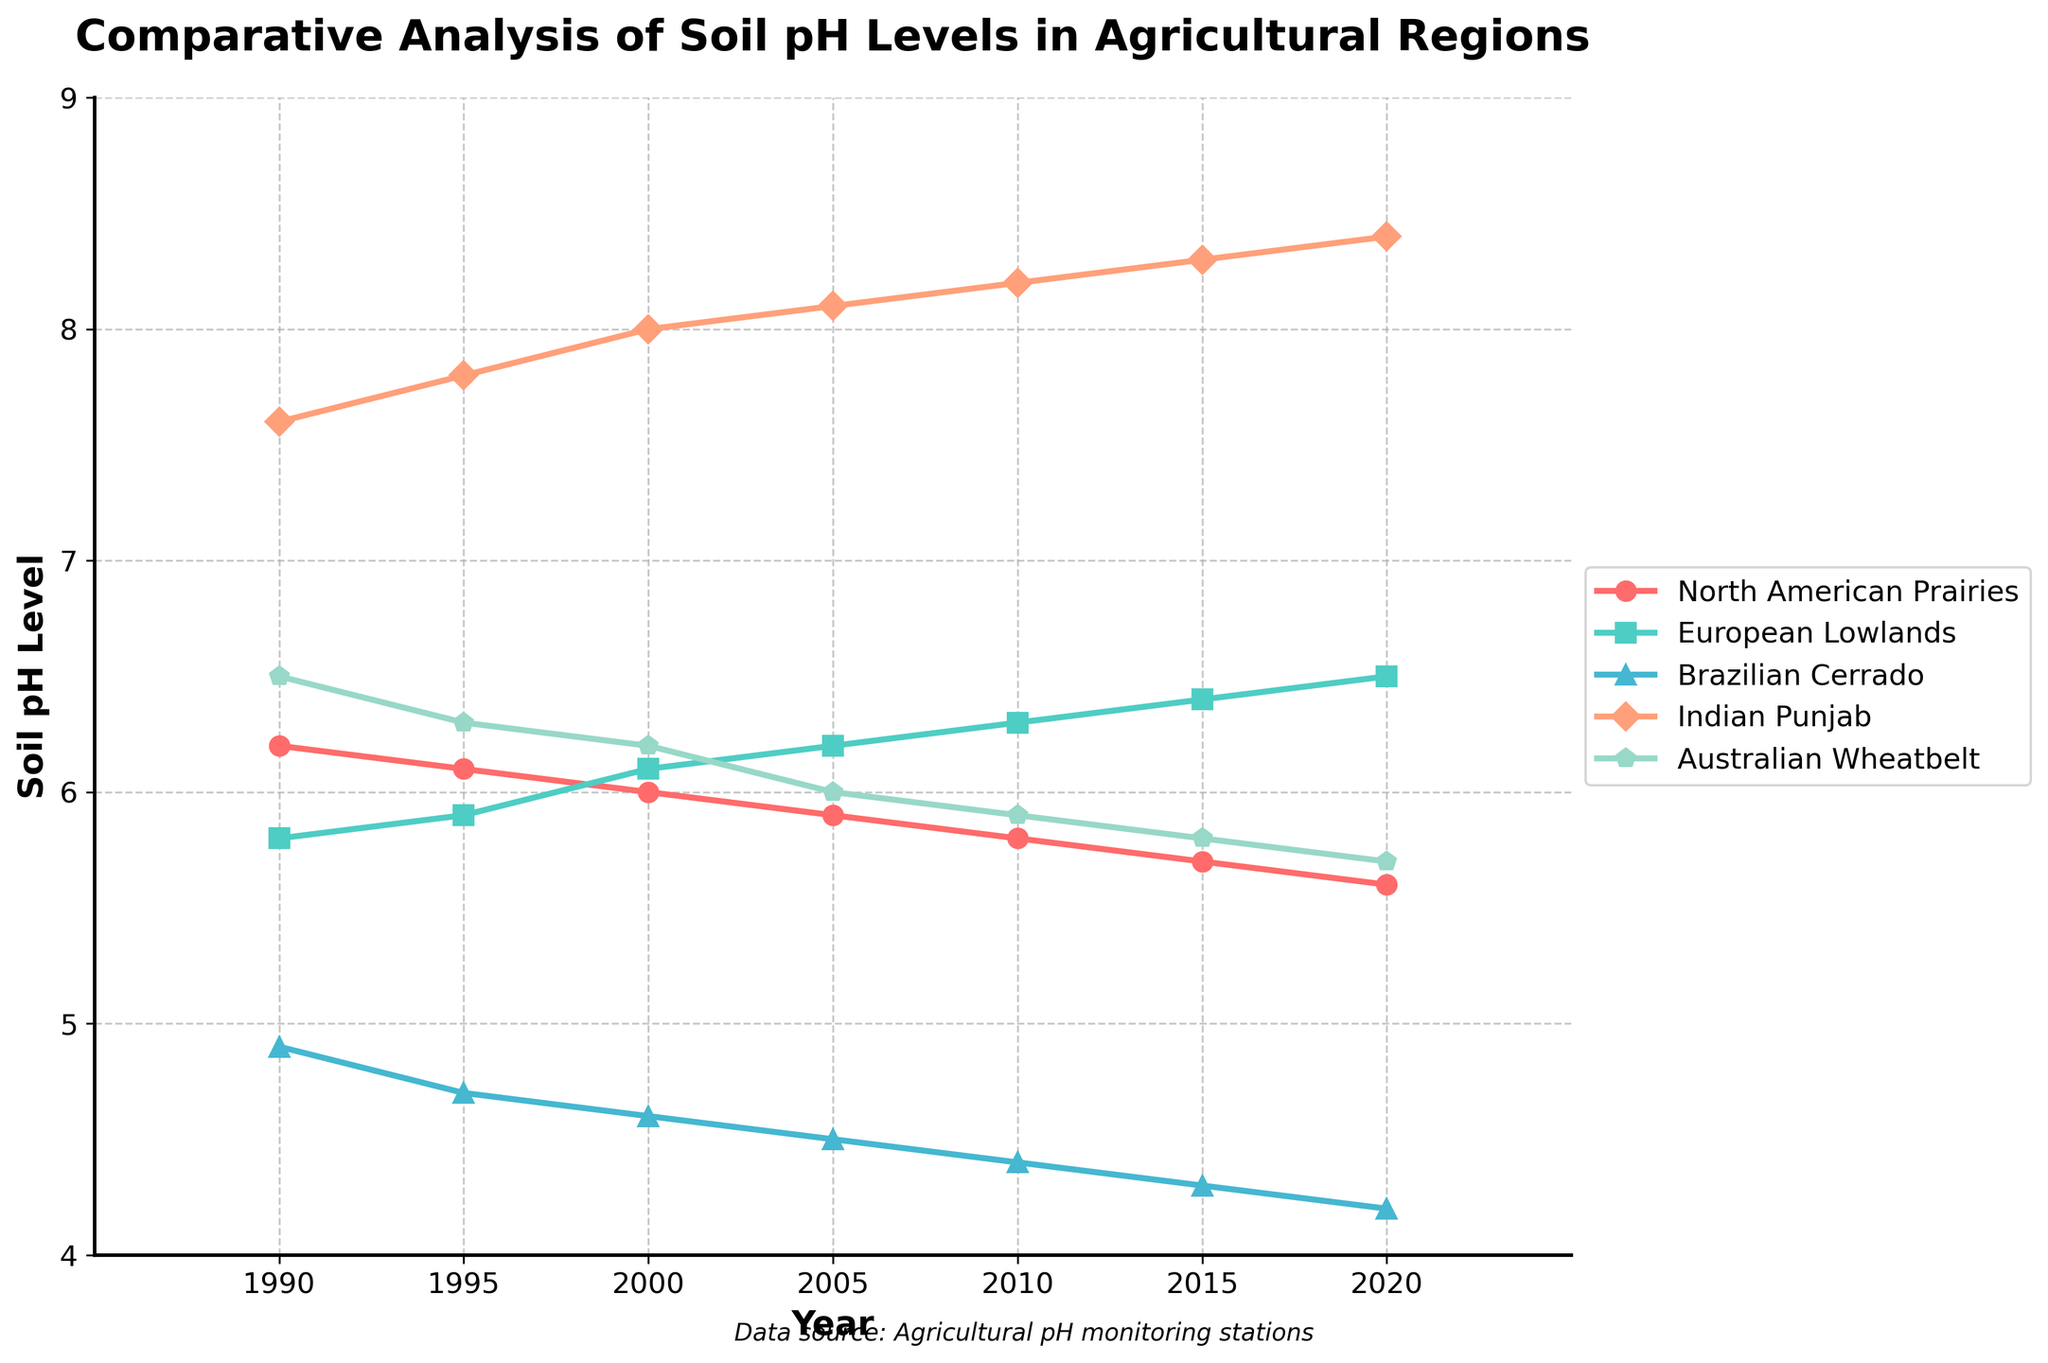Which region has shown the largest decrease in soil pH levels from 1990 to 2020? The soil pH levels in 1990 and 2020 for the regions are: North American Prairies (6.2 to 5.6), European Lowlands (5.8 to 6.5), Brazilian Cerrado (4.9 to 4.2), Indian Punjab (7.6 to 8.4), and Australian Wheatbelt (6.5 to 5.7). The largest decrease is calculated as: North American Prairies: 6.2 - 5.6 = 0.6, European Lowlands: 5.8 - 6.5 = -0.7 (increase), Brazilian Cerrado: 4.9 - 4.2 = 0.7, Indian Punjab: 7.6 - 8.4 = -0.8 (increase), and Australian Wheatbelt: 6.5 - 5.7 = 0.8. Therefore, the largest decrease is 0.8 for Australian Wheatbelt.
Answer: Australian Wheatbelt Which region had the highest soil pH level in 2020? By observing the y-axis values for the year 2020, the soil pH levels for each region are: North American Prairies (5.6), European Lowlands (6.5), Brazilian Cerrado (4.2), Indian Punjab (8.4), and Australian Wheatbelt (5.7). The highest pH level among these values is 8.4.
Answer: Indian Punjab Between 1990 and 2020, which region's pH level increased the most? By subtracting the pH values from 1990 and 2020 for each region, we get: North American Prairies (6.2 to 5.6, decrease of 0.6), European Lowlands (5.8 to 6.5, increase of 0.7), Brazilian Cerrado (4.9 to 4.2, decrease of 0.7), Indian Punjab (7.6 to 8.4, increase of 0.8), and Australian Wheatbelt (6.5 to 5.7, decrease of 0.8). The highest increase is 0.8 for Indian Punjab.
Answer: Indian Punjab What is the average soil pH level of the North American Prairies from 1990 to 2020? The pH levels of North American Prairies from 1990 to 2020 are 6.2, 6.1, 6.0, 5.9, 5.8, 5.7, and 5.6. Adding these values gives 41.3. The number of data points is 7. Therefore, the average pH level is 41.3 / 7 = 5.9.
Answer: 5.9 Compare the trend of pH levels in European Lowlands and Brazilian Cerrado between 1990 and 2020. Which region's pH level trend is more stable? Observing the lines representing European Lowlands and Brazilian Cerrado from 1990 to 2020, the European Lowlands' pH levels trend slightly upward, from 5.8 to 6.5. In contrast, the Brazilian Cerrado's pH levels consistently decrease from 4.9 to 4.2. The stability can be evaluated by the consistency and closeness of pH values across the timeline. European Lowlands' pH trend shows a gradual increase, while Brazilian Cerrado has a consistent decrease, indicating a more stable trend for European Lowlands.
Answer: European Lowlands In which year did the Australian Wheatbelt first record a pH level below 6? By looking at the pH values of the Australian Wheatbelt, we see they are: 1990 (6.5), 1995 (6.3), 2000 (6.2), 2005 (6.0), 2010 (5.9), 2015 (5.8), and 2020 (5.7). The first occurrence of a level below 6 is in 2010, which has a pH of 5.9.
Answer: 2010 Which region's soil pH increased continuously from 1990 to 2020? The soil pH of European Lowlands (5.8, 5.9, 6.1, 6.2, 6.3, 6.4, 6.5) and Indian Punjab (7.6, 7.8, 8.0, 8.1, 8.2, 8.3, 8.4) show a continuous increase from 1990 to 2020. Comparing trends, only these two regions consistently show an increase in pH levels year over year.
Answer: European Lowlands and Indian Punjab Calculate the range of soil pH levels for Brazilian Cerrado from 1990 to 2020. The range is determined by subtracting the minimum value from the maximum value. For Brazilian Cerrado, the pH levels are: 1990 (4.9), 1995 (4.7), 2000 (4.6), 2005 (4.5), 2010 (4.4), 2015 (4.3), and 2020 (4.2). The range is 4.9 - 4.2 = 0.7.
Answer: 0.7 